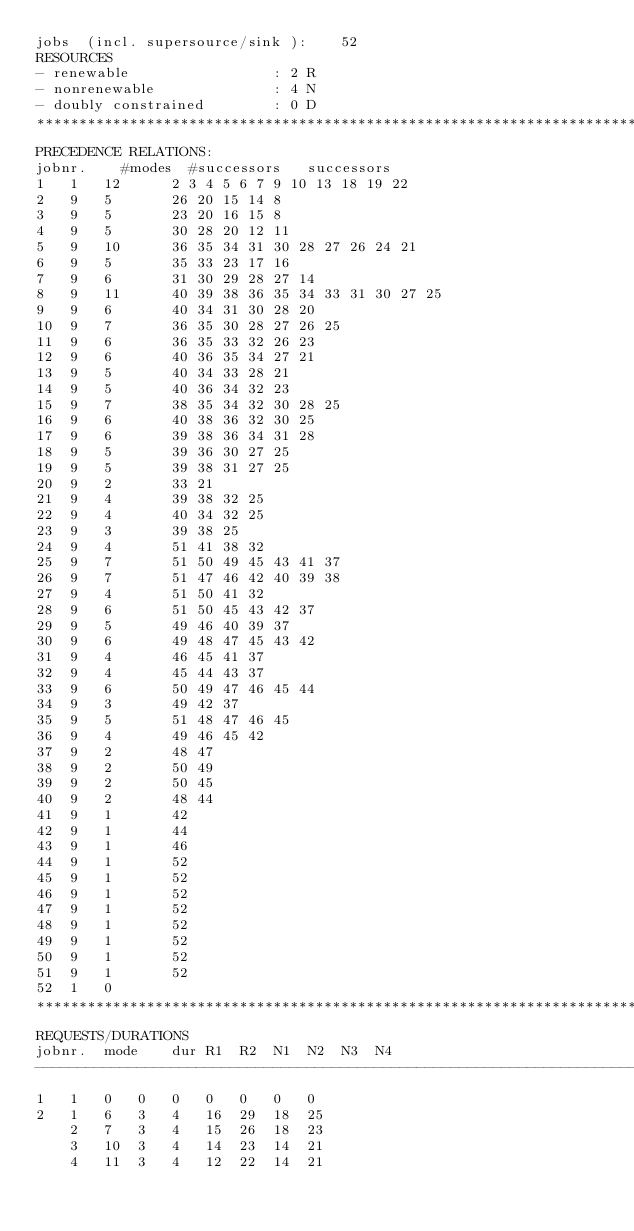<code> <loc_0><loc_0><loc_500><loc_500><_ObjectiveC_>jobs  (incl. supersource/sink ):	52
RESOURCES
- renewable                 : 2 R
- nonrenewable              : 4 N
- doubly constrained        : 0 D
************************************************************************
PRECEDENCE RELATIONS:
jobnr.    #modes  #successors   successors
1	1	12		2 3 4 5 6 7 9 10 13 18 19 22 
2	9	5		26 20 15 14 8 
3	9	5		23 20 16 15 8 
4	9	5		30 28 20 12 11 
5	9	10		36 35 34 31 30 28 27 26 24 21 
6	9	5		35 33 23 17 16 
7	9	6		31 30 29 28 27 14 
8	9	11		40 39 38 36 35 34 33 31 30 27 25 
9	9	6		40 34 31 30 28 20 
10	9	7		36 35 30 28 27 26 25 
11	9	6		36 35 33 32 26 23 
12	9	6		40 36 35 34 27 21 
13	9	5		40 34 33 28 21 
14	9	5		40 36 34 32 23 
15	9	7		38 35 34 32 30 28 25 
16	9	6		40 38 36 32 30 25 
17	9	6		39 38 36 34 31 28 
18	9	5		39 36 30 27 25 
19	9	5		39 38 31 27 25 
20	9	2		33 21 
21	9	4		39 38 32 25 
22	9	4		40 34 32 25 
23	9	3		39 38 25 
24	9	4		51 41 38 32 
25	9	7		51 50 49 45 43 41 37 
26	9	7		51 47 46 42 40 39 38 
27	9	4		51 50 41 32 
28	9	6		51 50 45 43 42 37 
29	9	5		49 46 40 39 37 
30	9	6		49 48 47 45 43 42 
31	9	4		46 45 41 37 
32	9	4		45 44 43 37 
33	9	6		50 49 47 46 45 44 
34	9	3		49 42 37 
35	9	5		51 48 47 46 45 
36	9	4		49 46 45 42 
37	9	2		48 47 
38	9	2		50 49 
39	9	2		50 45 
40	9	2		48 44 
41	9	1		42 
42	9	1		44 
43	9	1		46 
44	9	1		52 
45	9	1		52 
46	9	1		52 
47	9	1		52 
48	9	1		52 
49	9	1		52 
50	9	1		52 
51	9	1		52 
52	1	0		
************************************************************************
REQUESTS/DURATIONS
jobnr.	mode	dur	R1	R2	N1	N2	N3	N4	
------------------------------------------------------------------------
1	1	0	0	0	0	0	0	0	
2	1	6	3	4	16	29	18	25	
	2	7	3	4	15	26	18	23	
	3	10	3	4	14	23	14	21	
	4	11	3	4	12	22	14	21	</code> 